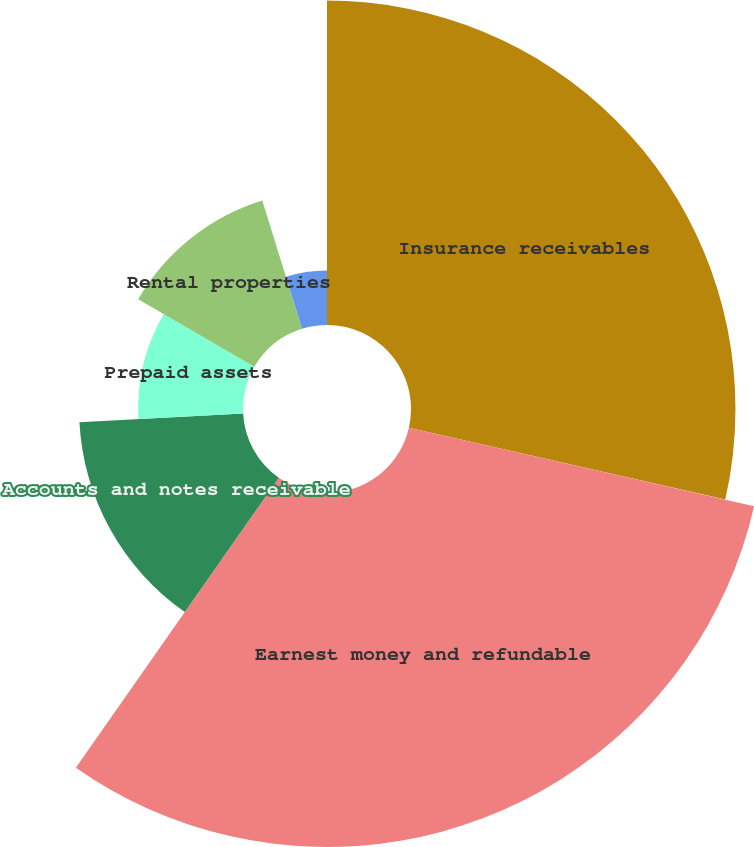<chart> <loc_0><loc_0><loc_500><loc_500><pie_chart><fcel>Insurance receivables<fcel>Earnest money and refundable<fcel>Accounts and notes receivable<fcel>Prepaid assets<fcel>Rental properties<fcel>Other assets<nl><fcel>28.56%<fcel>31.16%<fcel>14.43%<fcel>9.23%<fcel>11.83%<fcel>4.79%<nl></chart> 